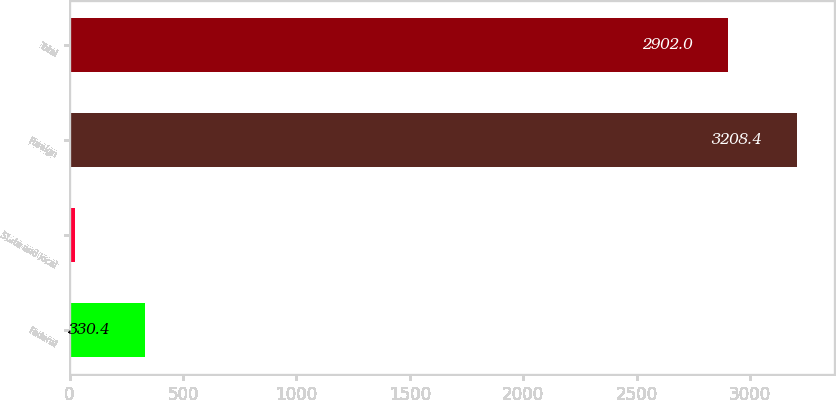<chart> <loc_0><loc_0><loc_500><loc_500><bar_chart><fcel>Federal<fcel>State and local<fcel>Foreign<fcel>Total<nl><fcel>330.4<fcel>24<fcel>3208.4<fcel>2902<nl></chart> 